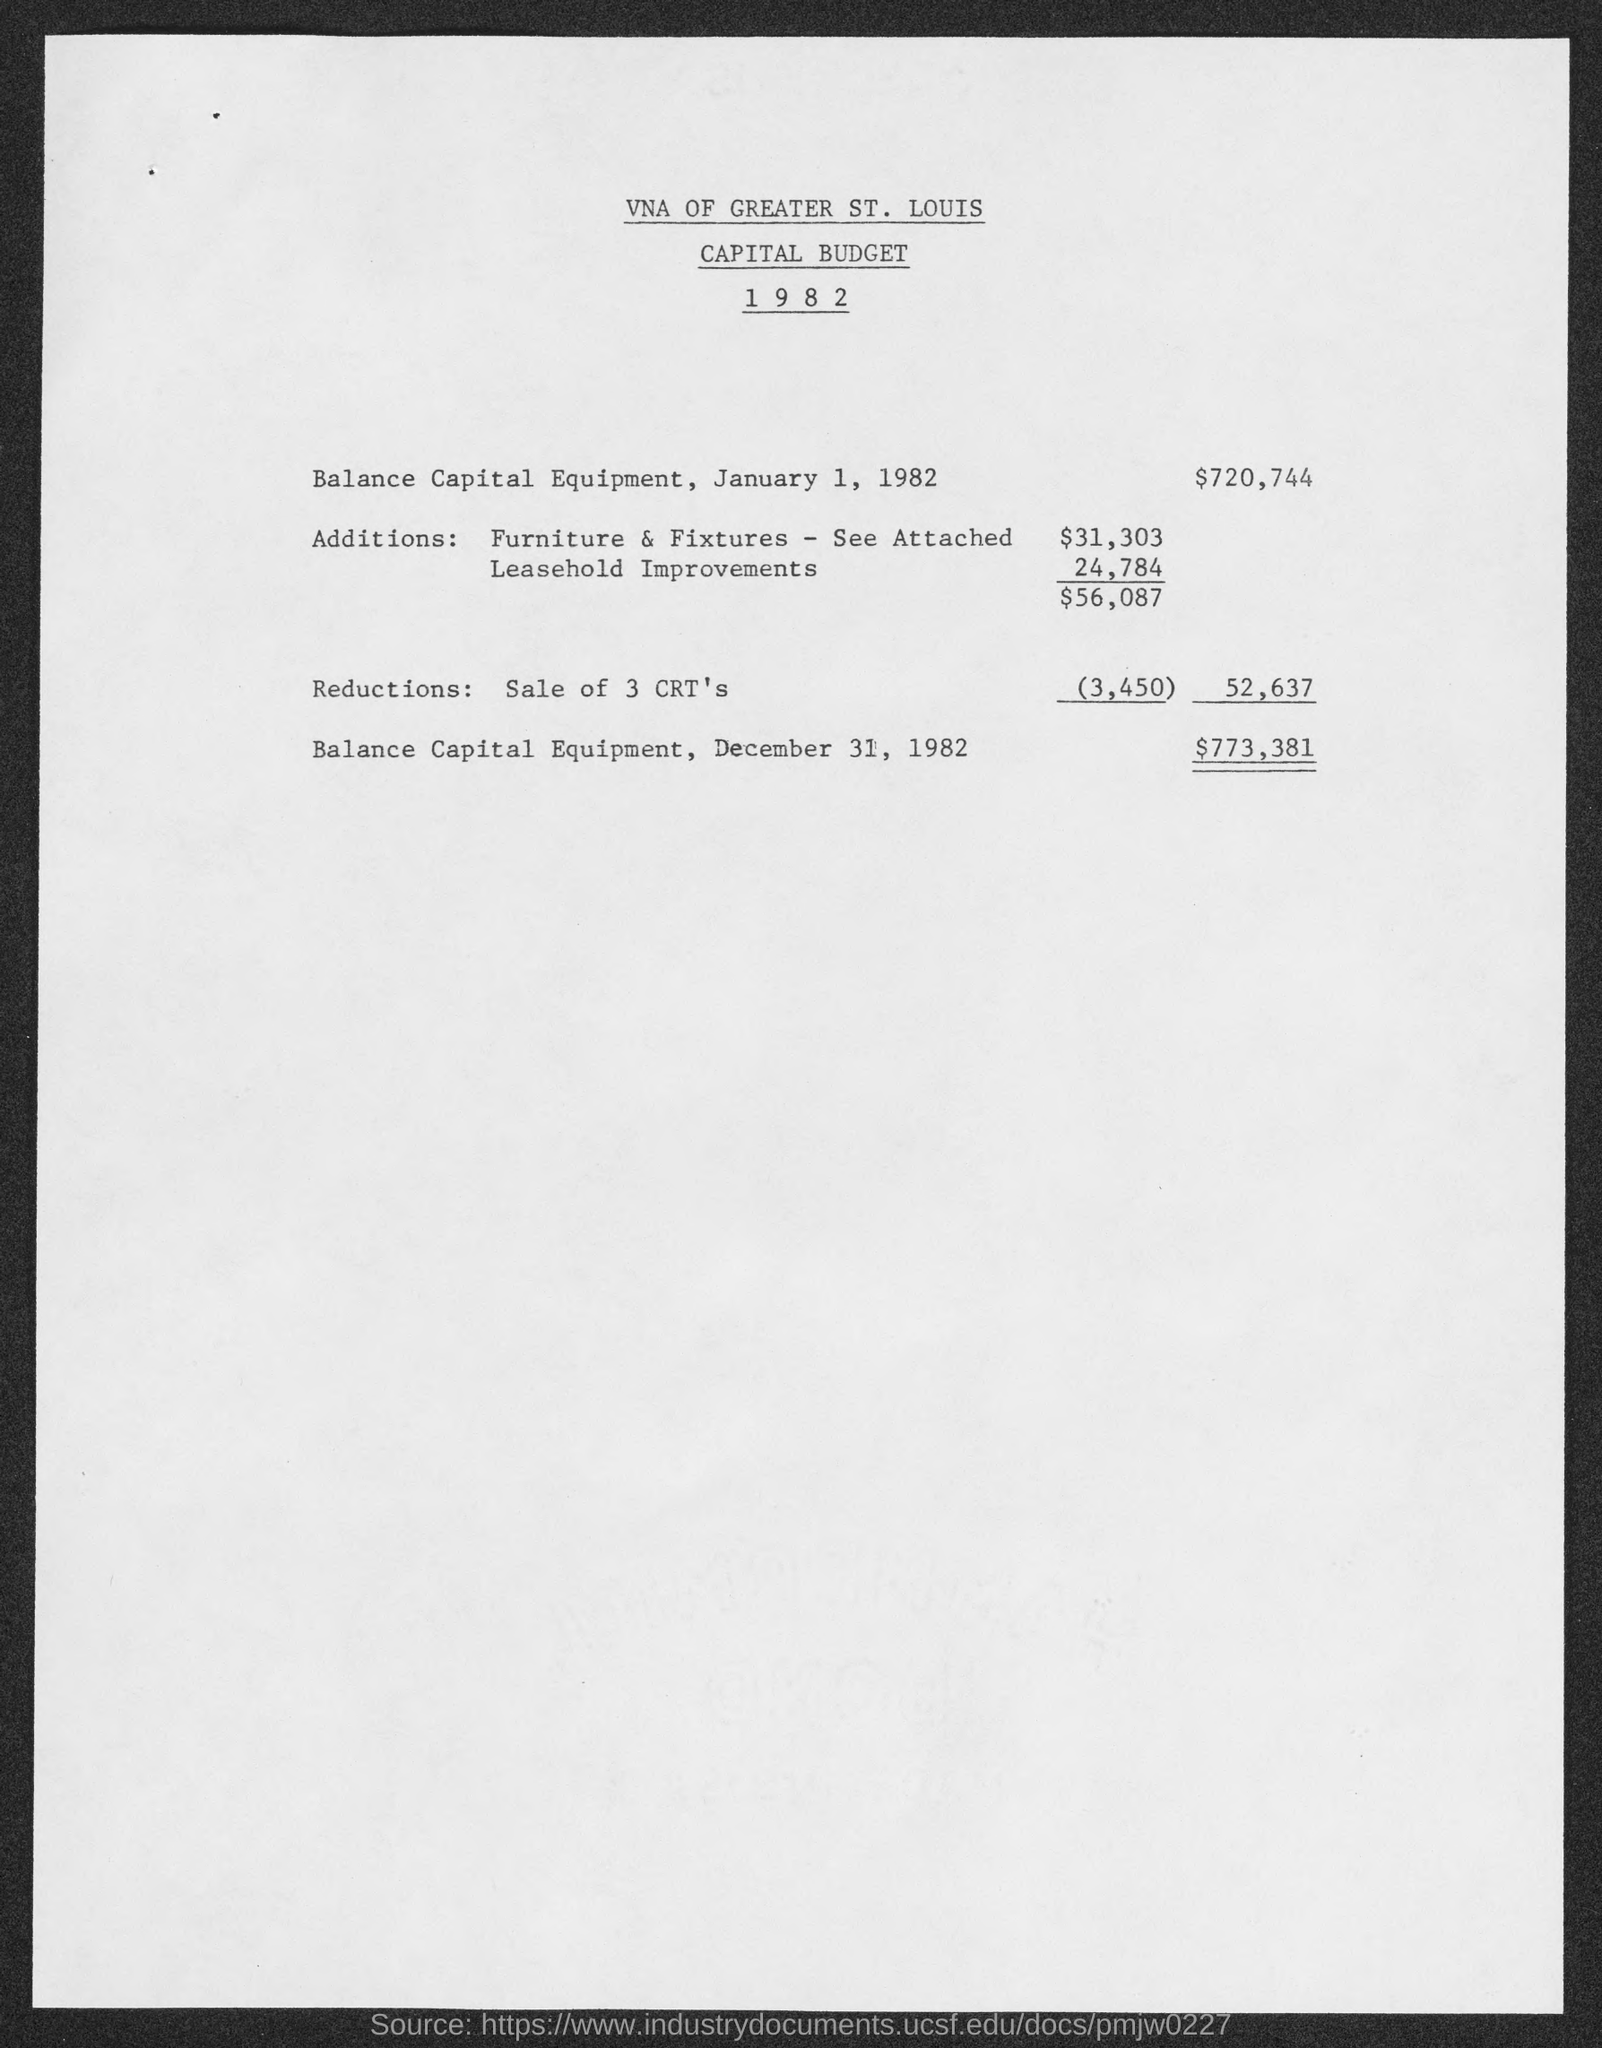What is the Balance Capital Equipment on January 1, 1982?
Your response must be concise. $720,744. What is the Balance Capital Equipment on December 31, 1982?
Offer a terse response. $773,381. Which company's capital budget is given here?
Keep it short and to the point. VNA OF GREATER ST. LOUIS. 